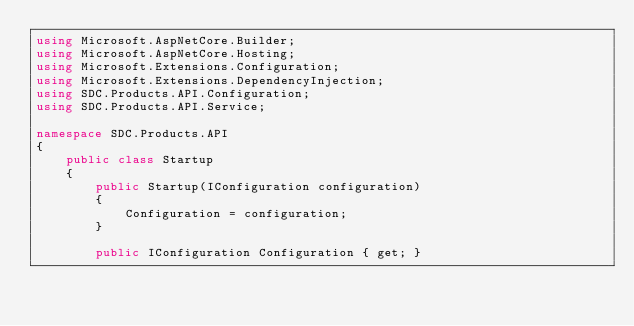<code> <loc_0><loc_0><loc_500><loc_500><_C#_>using Microsoft.AspNetCore.Builder;
using Microsoft.AspNetCore.Hosting;
using Microsoft.Extensions.Configuration;
using Microsoft.Extensions.DependencyInjection;
using SDC.Products.API.Configuration;
using SDC.Products.API.Service;

namespace SDC.Products.API
{
    public class Startup
    {
        public Startup(IConfiguration configuration)
        {
            Configuration = configuration;
        }

        public IConfiguration Configuration { get; }
</code> 